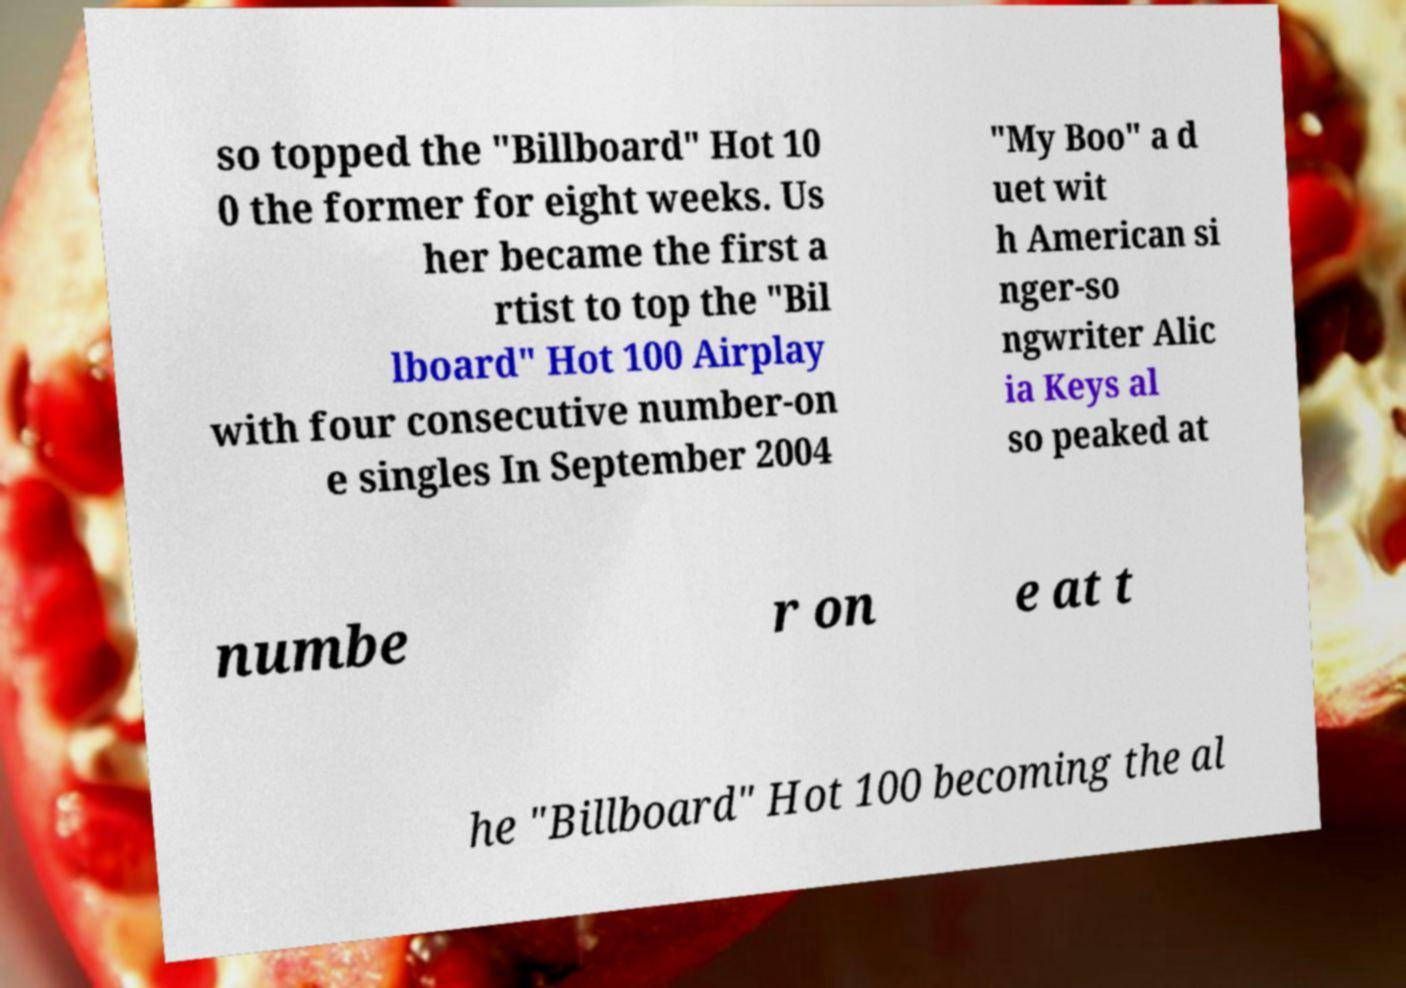Can you read and provide the text displayed in the image?This photo seems to have some interesting text. Can you extract and type it out for me? so topped the "Billboard" Hot 10 0 the former for eight weeks. Us her became the first a rtist to top the "Bil lboard" Hot 100 Airplay with four consecutive number-on e singles In September 2004 "My Boo" a d uet wit h American si nger-so ngwriter Alic ia Keys al so peaked at numbe r on e at t he "Billboard" Hot 100 becoming the al 